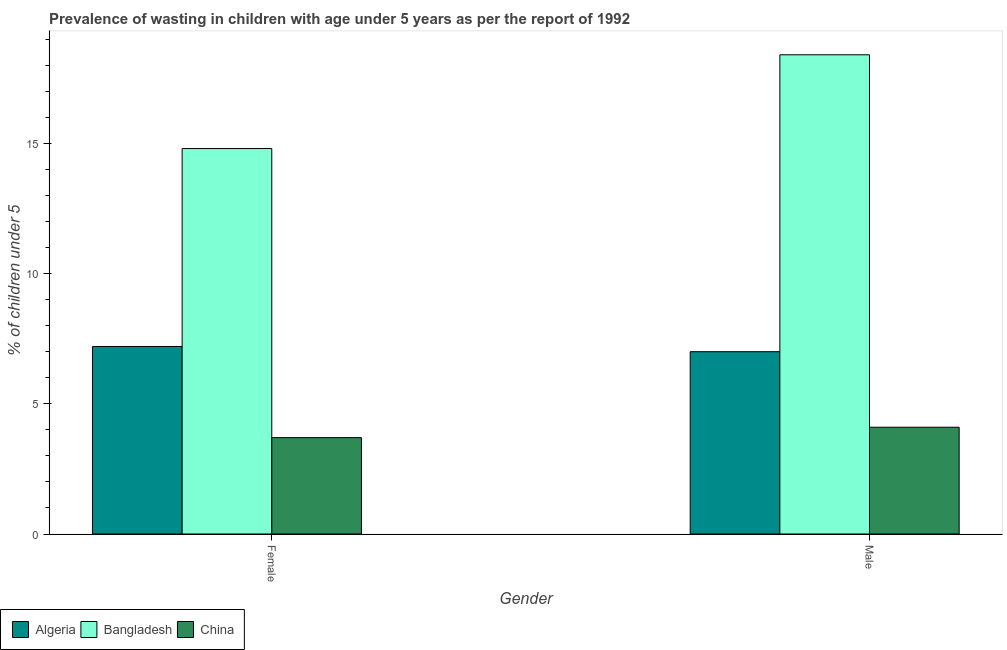How many groups of bars are there?
Your response must be concise. 2. Are the number of bars per tick equal to the number of legend labels?
Provide a succinct answer. Yes. Are the number of bars on each tick of the X-axis equal?
Provide a succinct answer. Yes. What is the label of the 1st group of bars from the left?
Your answer should be compact. Female. What is the percentage of undernourished female children in Algeria?
Give a very brief answer. 7.2. Across all countries, what is the maximum percentage of undernourished male children?
Give a very brief answer. 18.4. Across all countries, what is the minimum percentage of undernourished female children?
Make the answer very short. 3.7. In which country was the percentage of undernourished male children maximum?
Your answer should be very brief. Bangladesh. What is the total percentage of undernourished female children in the graph?
Your response must be concise. 25.7. What is the difference between the percentage of undernourished female children in Bangladesh and that in China?
Offer a very short reply. 11.1. What is the difference between the percentage of undernourished female children in China and the percentage of undernourished male children in Algeria?
Your answer should be compact. -3.3. What is the average percentage of undernourished female children per country?
Offer a very short reply. 8.57. What is the difference between the percentage of undernourished female children and percentage of undernourished male children in Algeria?
Provide a succinct answer. 0.2. In how many countries, is the percentage of undernourished male children greater than 4 %?
Your answer should be very brief. 3. What is the ratio of the percentage of undernourished male children in China to that in Algeria?
Offer a very short reply. 0.59. Is the percentage of undernourished male children in China less than that in Bangladesh?
Give a very brief answer. Yes. In how many countries, is the percentage of undernourished female children greater than the average percentage of undernourished female children taken over all countries?
Make the answer very short. 1. What does the 2nd bar from the right in Male represents?
Offer a terse response. Bangladesh. How many bars are there?
Make the answer very short. 6. How many countries are there in the graph?
Your answer should be compact. 3. Are the values on the major ticks of Y-axis written in scientific E-notation?
Provide a succinct answer. No. Where does the legend appear in the graph?
Your answer should be compact. Bottom left. How are the legend labels stacked?
Provide a short and direct response. Horizontal. What is the title of the graph?
Your answer should be compact. Prevalence of wasting in children with age under 5 years as per the report of 1992. Does "Middle income" appear as one of the legend labels in the graph?
Provide a short and direct response. No. What is the label or title of the X-axis?
Your answer should be compact. Gender. What is the label or title of the Y-axis?
Offer a terse response.  % of children under 5. What is the  % of children under 5 in Algeria in Female?
Your response must be concise. 7.2. What is the  % of children under 5 of Bangladesh in Female?
Your answer should be compact. 14.8. What is the  % of children under 5 of China in Female?
Offer a very short reply. 3.7. What is the  % of children under 5 in Bangladesh in Male?
Provide a short and direct response. 18.4. What is the  % of children under 5 in China in Male?
Ensure brevity in your answer.  4.1. Across all Gender, what is the maximum  % of children under 5 in Algeria?
Your answer should be compact. 7.2. Across all Gender, what is the maximum  % of children under 5 in Bangladesh?
Your answer should be very brief. 18.4. Across all Gender, what is the maximum  % of children under 5 in China?
Your answer should be compact. 4.1. Across all Gender, what is the minimum  % of children under 5 in Bangladesh?
Your response must be concise. 14.8. Across all Gender, what is the minimum  % of children under 5 of China?
Make the answer very short. 3.7. What is the total  % of children under 5 of Algeria in the graph?
Give a very brief answer. 14.2. What is the total  % of children under 5 in Bangladesh in the graph?
Offer a terse response. 33.2. What is the total  % of children under 5 of China in the graph?
Provide a succinct answer. 7.8. What is the difference between the  % of children under 5 of Algeria in Female and that in Male?
Offer a very short reply. 0.2. What is the difference between the  % of children under 5 in China in Female and that in Male?
Ensure brevity in your answer.  -0.4. What is the difference between the  % of children under 5 of Algeria in Female and the  % of children under 5 of Bangladesh in Male?
Your answer should be very brief. -11.2. What is the average  % of children under 5 in China per Gender?
Your response must be concise. 3.9. What is the difference between the  % of children under 5 of Algeria and  % of children under 5 of China in Female?
Keep it short and to the point. 3.5. What is the difference between the  % of children under 5 in Bangladesh and  % of children under 5 in China in Female?
Your response must be concise. 11.1. What is the difference between the  % of children under 5 in Algeria and  % of children under 5 in Bangladesh in Male?
Your response must be concise. -11.4. What is the ratio of the  % of children under 5 of Algeria in Female to that in Male?
Make the answer very short. 1.03. What is the ratio of the  % of children under 5 of Bangladesh in Female to that in Male?
Make the answer very short. 0.8. What is the ratio of the  % of children under 5 of China in Female to that in Male?
Keep it short and to the point. 0.9. What is the difference between the highest and the second highest  % of children under 5 of Algeria?
Keep it short and to the point. 0.2. What is the difference between the highest and the second highest  % of children under 5 of Bangladesh?
Keep it short and to the point. 3.6. What is the difference between the highest and the second highest  % of children under 5 of China?
Your answer should be very brief. 0.4. What is the difference between the highest and the lowest  % of children under 5 of Bangladesh?
Provide a succinct answer. 3.6. 